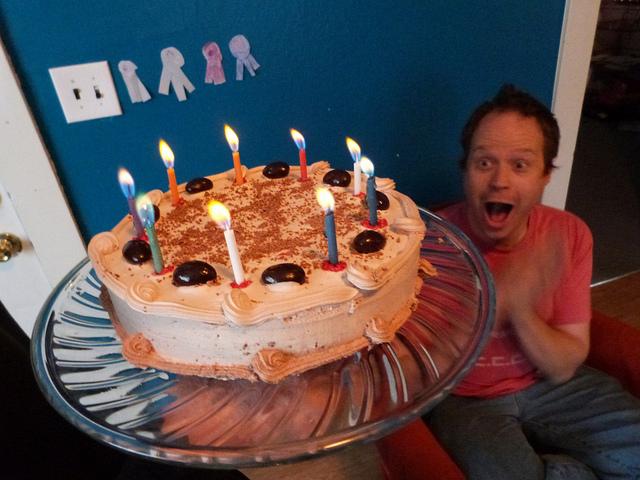What is the occasion?
Give a very brief answer. Birthday. How many candles are there?
Concise answer only. 9. What is on the plate?
Write a very short answer. Cake. 